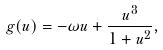Convert formula to latex. <formula><loc_0><loc_0><loc_500><loc_500>g ( u ) = - \omega u + \frac { u ^ { 3 } } { 1 + u ^ { 2 } } ,</formula> 